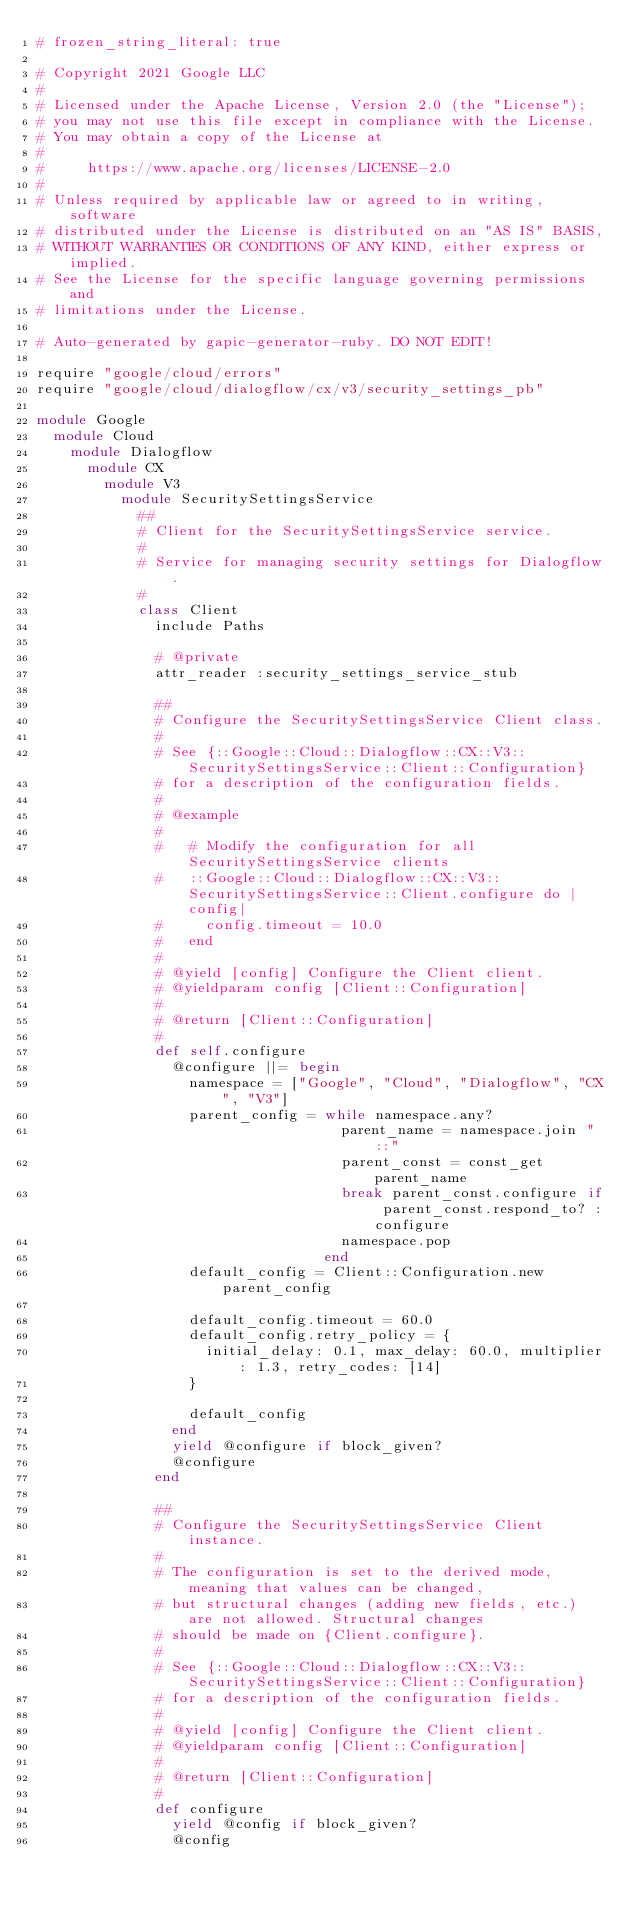Convert code to text. <code><loc_0><loc_0><loc_500><loc_500><_Ruby_># frozen_string_literal: true

# Copyright 2021 Google LLC
#
# Licensed under the Apache License, Version 2.0 (the "License");
# you may not use this file except in compliance with the License.
# You may obtain a copy of the License at
#
#     https://www.apache.org/licenses/LICENSE-2.0
#
# Unless required by applicable law or agreed to in writing, software
# distributed under the License is distributed on an "AS IS" BASIS,
# WITHOUT WARRANTIES OR CONDITIONS OF ANY KIND, either express or implied.
# See the License for the specific language governing permissions and
# limitations under the License.

# Auto-generated by gapic-generator-ruby. DO NOT EDIT!

require "google/cloud/errors"
require "google/cloud/dialogflow/cx/v3/security_settings_pb"

module Google
  module Cloud
    module Dialogflow
      module CX
        module V3
          module SecuritySettingsService
            ##
            # Client for the SecuritySettingsService service.
            #
            # Service for managing security settings for Dialogflow.
            #
            class Client
              include Paths

              # @private
              attr_reader :security_settings_service_stub

              ##
              # Configure the SecuritySettingsService Client class.
              #
              # See {::Google::Cloud::Dialogflow::CX::V3::SecuritySettingsService::Client::Configuration}
              # for a description of the configuration fields.
              #
              # @example
              #
              #   # Modify the configuration for all SecuritySettingsService clients
              #   ::Google::Cloud::Dialogflow::CX::V3::SecuritySettingsService::Client.configure do |config|
              #     config.timeout = 10.0
              #   end
              #
              # @yield [config] Configure the Client client.
              # @yieldparam config [Client::Configuration]
              #
              # @return [Client::Configuration]
              #
              def self.configure
                @configure ||= begin
                  namespace = ["Google", "Cloud", "Dialogflow", "CX", "V3"]
                  parent_config = while namespace.any?
                                    parent_name = namespace.join "::"
                                    parent_const = const_get parent_name
                                    break parent_const.configure if parent_const.respond_to? :configure
                                    namespace.pop
                                  end
                  default_config = Client::Configuration.new parent_config

                  default_config.timeout = 60.0
                  default_config.retry_policy = {
                    initial_delay: 0.1, max_delay: 60.0, multiplier: 1.3, retry_codes: [14]
                  }

                  default_config
                end
                yield @configure if block_given?
                @configure
              end

              ##
              # Configure the SecuritySettingsService Client instance.
              #
              # The configuration is set to the derived mode, meaning that values can be changed,
              # but structural changes (adding new fields, etc.) are not allowed. Structural changes
              # should be made on {Client.configure}.
              #
              # See {::Google::Cloud::Dialogflow::CX::V3::SecuritySettingsService::Client::Configuration}
              # for a description of the configuration fields.
              #
              # @yield [config] Configure the Client client.
              # @yieldparam config [Client::Configuration]
              #
              # @return [Client::Configuration]
              #
              def configure
                yield @config if block_given?
                @config</code> 